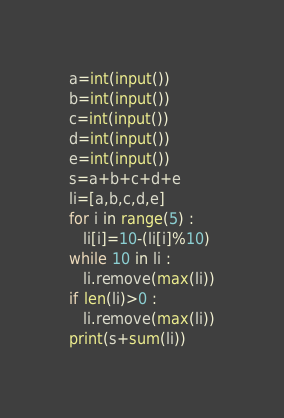Convert code to text. <code><loc_0><loc_0><loc_500><loc_500><_Python_>a=int(input())
b=int(input())
c=int(input())
d=int(input())
e=int(input())
s=a+b+c+d+e
li=[a,b,c,d,e]
for i in range(5) :
   li[i]=10-(li[i]%10)
while 10 in li :
   li.remove(max(li))
if len(li)>0 :
   li.remove(max(li))
print(s+sum(li))</code> 